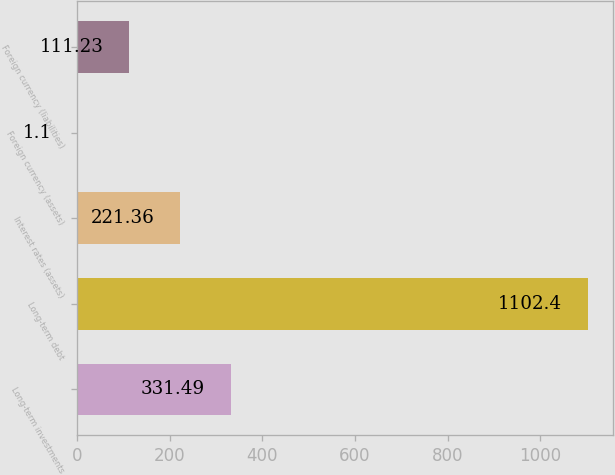Convert chart. <chart><loc_0><loc_0><loc_500><loc_500><bar_chart><fcel>Long-term investments<fcel>Long-term debt<fcel>Interest rates (assets)<fcel>Foreign currency (assets)<fcel>Foreign currency (liabilities)<nl><fcel>331.49<fcel>1102.4<fcel>221.36<fcel>1.1<fcel>111.23<nl></chart> 